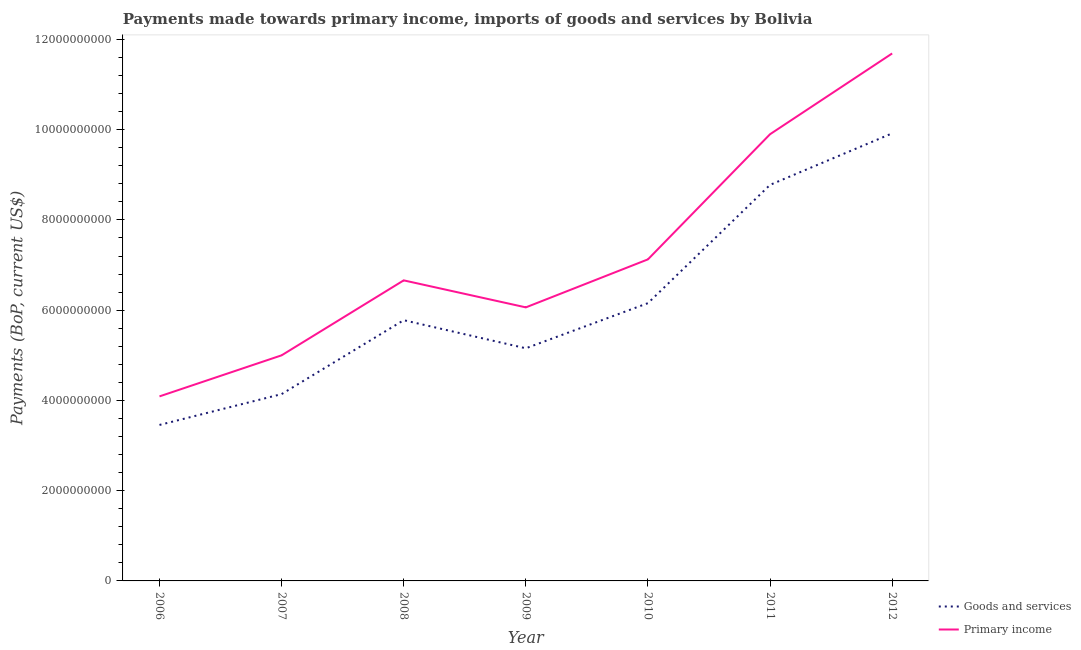How many different coloured lines are there?
Provide a succinct answer. 2. What is the payments made towards primary income in 2010?
Keep it short and to the point. 7.13e+09. Across all years, what is the maximum payments made towards goods and services?
Keep it short and to the point. 9.92e+09. Across all years, what is the minimum payments made towards primary income?
Ensure brevity in your answer.  4.09e+09. What is the total payments made towards goods and services in the graph?
Offer a terse response. 4.34e+1. What is the difference between the payments made towards goods and services in 2008 and that in 2012?
Make the answer very short. -4.14e+09. What is the difference between the payments made towards goods and services in 2011 and the payments made towards primary income in 2010?
Provide a succinct answer. 1.65e+09. What is the average payments made towards goods and services per year?
Provide a short and direct response. 6.20e+09. In the year 2010, what is the difference between the payments made towards goods and services and payments made towards primary income?
Your answer should be compact. -9.71e+08. In how many years, is the payments made towards goods and services greater than 10400000000 US$?
Ensure brevity in your answer.  0. What is the ratio of the payments made towards goods and services in 2006 to that in 2010?
Offer a terse response. 0.56. Is the payments made towards primary income in 2008 less than that in 2009?
Provide a short and direct response. No. What is the difference between the highest and the second highest payments made towards primary income?
Provide a short and direct response. 1.79e+09. What is the difference between the highest and the lowest payments made towards primary income?
Your answer should be compact. 7.60e+09. In how many years, is the payments made towards primary income greater than the average payments made towards primary income taken over all years?
Your answer should be compact. 2. Is the sum of the payments made towards goods and services in 2008 and 2010 greater than the maximum payments made towards primary income across all years?
Ensure brevity in your answer.  Yes. Does the payments made towards primary income monotonically increase over the years?
Your answer should be compact. No. Is the payments made towards primary income strictly greater than the payments made towards goods and services over the years?
Your answer should be compact. Yes. How many lines are there?
Your answer should be very brief. 2. Where does the legend appear in the graph?
Provide a short and direct response. Bottom right. How are the legend labels stacked?
Offer a terse response. Vertical. What is the title of the graph?
Your answer should be very brief. Payments made towards primary income, imports of goods and services by Bolivia. Does "Current US$" appear as one of the legend labels in the graph?
Provide a succinct answer. No. What is the label or title of the Y-axis?
Your answer should be very brief. Payments (BoP, current US$). What is the Payments (BoP, current US$) of Goods and services in 2006?
Ensure brevity in your answer.  3.46e+09. What is the Payments (BoP, current US$) in Primary income in 2006?
Make the answer very short. 4.09e+09. What is the Payments (BoP, current US$) of Goods and services in 2007?
Provide a succinct answer. 4.14e+09. What is the Payments (BoP, current US$) in Primary income in 2007?
Make the answer very short. 5.00e+09. What is the Payments (BoP, current US$) in Goods and services in 2008?
Ensure brevity in your answer.  5.78e+09. What is the Payments (BoP, current US$) in Primary income in 2008?
Ensure brevity in your answer.  6.66e+09. What is the Payments (BoP, current US$) of Goods and services in 2009?
Offer a terse response. 5.16e+09. What is the Payments (BoP, current US$) of Primary income in 2009?
Your response must be concise. 6.06e+09. What is the Payments (BoP, current US$) in Goods and services in 2010?
Give a very brief answer. 6.16e+09. What is the Payments (BoP, current US$) in Primary income in 2010?
Offer a terse response. 7.13e+09. What is the Payments (BoP, current US$) in Goods and services in 2011?
Your response must be concise. 8.78e+09. What is the Payments (BoP, current US$) in Primary income in 2011?
Provide a short and direct response. 9.90e+09. What is the Payments (BoP, current US$) in Goods and services in 2012?
Offer a terse response. 9.92e+09. What is the Payments (BoP, current US$) in Primary income in 2012?
Offer a terse response. 1.17e+1. Across all years, what is the maximum Payments (BoP, current US$) of Goods and services?
Provide a succinct answer. 9.92e+09. Across all years, what is the maximum Payments (BoP, current US$) in Primary income?
Provide a succinct answer. 1.17e+1. Across all years, what is the minimum Payments (BoP, current US$) of Goods and services?
Give a very brief answer. 3.46e+09. Across all years, what is the minimum Payments (BoP, current US$) in Primary income?
Your response must be concise. 4.09e+09. What is the total Payments (BoP, current US$) in Goods and services in the graph?
Provide a succinct answer. 4.34e+1. What is the total Payments (BoP, current US$) of Primary income in the graph?
Keep it short and to the point. 5.05e+1. What is the difference between the Payments (BoP, current US$) in Goods and services in 2006 and that in 2007?
Offer a terse response. -6.83e+08. What is the difference between the Payments (BoP, current US$) in Primary income in 2006 and that in 2007?
Provide a short and direct response. -9.10e+08. What is the difference between the Payments (BoP, current US$) in Goods and services in 2006 and that in 2008?
Offer a terse response. -2.32e+09. What is the difference between the Payments (BoP, current US$) of Primary income in 2006 and that in 2008?
Offer a terse response. -2.57e+09. What is the difference between the Payments (BoP, current US$) in Goods and services in 2006 and that in 2009?
Ensure brevity in your answer.  -1.70e+09. What is the difference between the Payments (BoP, current US$) in Primary income in 2006 and that in 2009?
Offer a terse response. -1.97e+09. What is the difference between the Payments (BoP, current US$) in Goods and services in 2006 and that in 2010?
Your response must be concise. -2.70e+09. What is the difference between the Payments (BoP, current US$) of Primary income in 2006 and that in 2010?
Your answer should be very brief. -3.04e+09. What is the difference between the Payments (BoP, current US$) of Goods and services in 2006 and that in 2011?
Keep it short and to the point. -5.32e+09. What is the difference between the Payments (BoP, current US$) of Primary income in 2006 and that in 2011?
Provide a succinct answer. -5.81e+09. What is the difference between the Payments (BoP, current US$) of Goods and services in 2006 and that in 2012?
Make the answer very short. -6.46e+09. What is the difference between the Payments (BoP, current US$) of Primary income in 2006 and that in 2012?
Your answer should be very brief. -7.60e+09. What is the difference between the Payments (BoP, current US$) of Goods and services in 2007 and that in 2008?
Offer a very short reply. -1.64e+09. What is the difference between the Payments (BoP, current US$) of Primary income in 2007 and that in 2008?
Your response must be concise. -1.66e+09. What is the difference between the Payments (BoP, current US$) of Goods and services in 2007 and that in 2009?
Give a very brief answer. -1.02e+09. What is the difference between the Payments (BoP, current US$) in Primary income in 2007 and that in 2009?
Your response must be concise. -1.06e+09. What is the difference between the Payments (BoP, current US$) in Goods and services in 2007 and that in 2010?
Make the answer very short. -2.02e+09. What is the difference between the Payments (BoP, current US$) of Primary income in 2007 and that in 2010?
Your response must be concise. -2.13e+09. What is the difference between the Payments (BoP, current US$) of Goods and services in 2007 and that in 2011?
Offer a very short reply. -4.64e+09. What is the difference between the Payments (BoP, current US$) of Primary income in 2007 and that in 2011?
Your response must be concise. -4.90e+09. What is the difference between the Payments (BoP, current US$) in Goods and services in 2007 and that in 2012?
Your response must be concise. -5.78e+09. What is the difference between the Payments (BoP, current US$) of Primary income in 2007 and that in 2012?
Your answer should be very brief. -6.69e+09. What is the difference between the Payments (BoP, current US$) of Goods and services in 2008 and that in 2009?
Provide a succinct answer. 6.22e+08. What is the difference between the Payments (BoP, current US$) in Primary income in 2008 and that in 2009?
Offer a terse response. 5.99e+08. What is the difference between the Payments (BoP, current US$) of Goods and services in 2008 and that in 2010?
Make the answer very short. -3.77e+08. What is the difference between the Payments (BoP, current US$) in Primary income in 2008 and that in 2010?
Ensure brevity in your answer.  -4.65e+08. What is the difference between the Payments (BoP, current US$) of Goods and services in 2008 and that in 2011?
Provide a succinct answer. -3.00e+09. What is the difference between the Payments (BoP, current US$) in Primary income in 2008 and that in 2011?
Make the answer very short. -3.24e+09. What is the difference between the Payments (BoP, current US$) of Goods and services in 2008 and that in 2012?
Offer a very short reply. -4.14e+09. What is the difference between the Payments (BoP, current US$) in Primary income in 2008 and that in 2012?
Offer a very short reply. -5.03e+09. What is the difference between the Payments (BoP, current US$) of Goods and services in 2009 and that in 2010?
Provide a succinct answer. -1.00e+09. What is the difference between the Payments (BoP, current US$) in Primary income in 2009 and that in 2010?
Offer a terse response. -1.06e+09. What is the difference between the Payments (BoP, current US$) in Goods and services in 2009 and that in 2011?
Keep it short and to the point. -3.62e+09. What is the difference between the Payments (BoP, current US$) in Primary income in 2009 and that in 2011?
Keep it short and to the point. -3.84e+09. What is the difference between the Payments (BoP, current US$) of Goods and services in 2009 and that in 2012?
Offer a terse response. -4.76e+09. What is the difference between the Payments (BoP, current US$) in Primary income in 2009 and that in 2012?
Give a very brief answer. -5.63e+09. What is the difference between the Payments (BoP, current US$) in Goods and services in 2010 and that in 2011?
Provide a short and direct response. -2.62e+09. What is the difference between the Payments (BoP, current US$) in Primary income in 2010 and that in 2011?
Make the answer very short. -2.77e+09. What is the difference between the Payments (BoP, current US$) of Goods and services in 2010 and that in 2012?
Your response must be concise. -3.76e+09. What is the difference between the Payments (BoP, current US$) of Primary income in 2010 and that in 2012?
Offer a very short reply. -4.56e+09. What is the difference between the Payments (BoP, current US$) in Goods and services in 2011 and that in 2012?
Offer a very short reply. -1.14e+09. What is the difference between the Payments (BoP, current US$) of Primary income in 2011 and that in 2012?
Ensure brevity in your answer.  -1.79e+09. What is the difference between the Payments (BoP, current US$) of Goods and services in 2006 and the Payments (BoP, current US$) of Primary income in 2007?
Offer a terse response. -1.54e+09. What is the difference between the Payments (BoP, current US$) of Goods and services in 2006 and the Payments (BoP, current US$) of Primary income in 2008?
Give a very brief answer. -3.20e+09. What is the difference between the Payments (BoP, current US$) in Goods and services in 2006 and the Payments (BoP, current US$) in Primary income in 2009?
Give a very brief answer. -2.61e+09. What is the difference between the Payments (BoP, current US$) in Goods and services in 2006 and the Payments (BoP, current US$) in Primary income in 2010?
Offer a terse response. -3.67e+09. What is the difference between the Payments (BoP, current US$) of Goods and services in 2006 and the Payments (BoP, current US$) of Primary income in 2011?
Your response must be concise. -6.44e+09. What is the difference between the Payments (BoP, current US$) in Goods and services in 2006 and the Payments (BoP, current US$) in Primary income in 2012?
Your answer should be compact. -8.23e+09. What is the difference between the Payments (BoP, current US$) of Goods and services in 2007 and the Payments (BoP, current US$) of Primary income in 2008?
Your answer should be compact. -2.52e+09. What is the difference between the Payments (BoP, current US$) in Goods and services in 2007 and the Payments (BoP, current US$) in Primary income in 2009?
Your response must be concise. -1.92e+09. What is the difference between the Payments (BoP, current US$) of Goods and services in 2007 and the Payments (BoP, current US$) of Primary income in 2010?
Keep it short and to the point. -2.99e+09. What is the difference between the Payments (BoP, current US$) in Goods and services in 2007 and the Payments (BoP, current US$) in Primary income in 2011?
Ensure brevity in your answer.  -5.76e+09. What is the difference between the Payments (BoP, current US$) of Goods and services in 2007 and the Payments (BoP, current US$) of Primary income in 2012?
Your answer should be very brief. -7.55e+09. What is the difference between the Payments (BoP, current US$) in Goods and services in 2008 and the Payments (BoP, current US$) in Primary income in 2009?
Give a very brief answer. -2.84e+08. What is the difference between the Payments (BoP, current US$) of Goods and services in 2008 and the Payments (BoP, current US$) of Primary income in 2010?
Provide a succinct answer. -1.35e+09. What is the difference between the Payments (BoP, current US$) of Goods and services in 2008 and the Payments (BoP, current US$) of Primary income in 2011?
Your answer should be very brief. -4.12e+09. What is the difference between the Payments (BoP, current US$) of Goods and services in 2008 and the Payments (BoP, current US$) of Primary income in 2012?
Keep it short and to the point. -5.91e+09. What is the difference between the Payments (BoP, current US$) of Goods and services in 2009 and the Payments (BoP, current US$) of Primary income in 2010?
Make the answer very short. -1.97e+09. What is the difference between the Payments (BoP, current US$) in Goods and services in 2009 and the Payments (BoP, current US$) in Primary income in 2011?
Offer a very short reply. -4.74e+09. What is the difference between the Payments (BoP, current US$) of Goods and services in 2009 and the Payments (BoP, current US$) of Primary income in 2012?
Your answer should be very brief. -6.53e+09. What is the difference between the Payments (BoP, current US$) in Goods and services in 2010 and the Payments (BoP, current US$) in Primary income in 2011?
Your response must be concise. -3.74e+09. What is the difference between the Payments (BoP, current US$) of Goods and services in 2010 and the Payments (BoP, current US$) of Primary income in 2012?
Provide a short and direct response. -5.53e+09. What is the difference between the Payments (BoP, current US$) of Goods and services in 2011 and the Payments (BoP, current US$) of Primary income in 2012?
Ensure brevity in your answer.  -2.91e+09. What is the average Payments (BoP, current US$) of Goods and services per year?
Offer a very short reply. 6.20e+09. What is the average Payments (BoP, current US$) in Primary income per year?
Your answer should be very brief. 7.22e+09. In the year 2006, what is the difference between the Payments (BoP, current US$) in Goods and services and Payments (BoP, current US$) in Primary income?
Ensure brevity in your answer.  -6.33e+08. In the year 2007, what is the difference between the Payments (BoP, current US$) in Goods and services and Payments (BoP, current US$) in Primary income?
Your answer should be compact. -8.59e+08. In the year 2008, what is the difference between the Payments (BoP, current US$) in Goods and services and Payments (BoP, current US$) in Primary income?
Ensure brevity in your answer.  -8.83e+08. In the year 2009, what is the difference between the Payments (BoP, current US$) in Goods and services and Payments (BoP, current US$) in Primary income?
Give a very brief answer. -9.06e+08. In the year 2010, what is the difference between the Payments (BoP, current US$) of Goods and services and Payments (BoP, current US$) of Primary income?
Your response must be concise. -9.71e+08. In the year 2011, what is the difference between the Payments (BoP, current US$) of Goods and services and Payments (BoP, current US$) of Primary income?
Give a very brief answer. -1.12e+09. In the year 2012, what is the difference between the Payments (BoP, current US$) in Goods and services and Payments (BoP, current US$) in Primary income?
Give a very brief answer. -1.77e+09. What is the ratio of the Payments (BoP, current US$) of Goods and services in 2006 to that in 2007?
Offer a very short reply. 0.83. What is the ratio of the Payments (BoP, current US$) of Primary income in 2006 to that in 2007?
Offer a very short reply. 0.82. What is the ratio of the Payments (BoP, current US$) of Goods and services in 2006 to that in 2008?
Provide a succinct answer. 0.6. What is the ratio of the Payments (BoP, current US$) of Primary income in 2006 to that in 2008?
Make the answer very short. 0.61. What is the ratio of the Payments (BoP, current US$) of Goods and services in 2006 to that in 2009?
Make the answer very short. 0.67. What is the ratio of the Payments (BoP, current US$) in Primary income in 2006 to that in 2009?
Give a very brief answer. 0.67. What is the ratio of the Payments (BoP, current US$) in Goods and services in 2006 to that in 2010?
Offer a very short reply. 0.56. What is the ratio of the Payments (BoP, current US$) of Primary income in 2006 to that in 2010?
Provide a short and direct response. 0.57. What is the ratio of the Payments (BoP, current US$) in Goods and services in 2006 to that in 2011?
Provide a succinct answer. 0.39. What is the ratio of the Payments (BoP, current US$) in Primary income in 2006 to that in 2011?
Ensure brevity in your answer.  0.41. What is the ratio of the Payments (BoP, current US$) in Goods and services in 2006 to that in 2012?
Offer a very short reply. 0.35. What is the ratio of the Payments (BoP, current US$) of Primary income in 2006 to that in 2012?
Give a very brief answer. 0.35. What is the ratio of the Payments (BoP, current US$) in Goods and services in 2007 to that in 2008?
Your answer should be compact. 0.72. What is the ratio of the Payments (BoP, current US$) in Primary income in 2007 to that in 2008?
Make the answer very short. 0.75. What is the ratio of the Payments (BoP, current US$) in Goods and services in 2007 to that in 2009?
Offer a very short reply. 0.8. What is the ratio of the Payments (BoP, current US$) in Primary income in 2007 to that in 2009?
Provide a short and direct response. 0.82. What is the ratio of the Payments (BoP, current US$) of Goods and services in 2007 to that in 2010?
Your answer should be very brief. 0.67. What is the ratio of the Payments (BoP, current US$) in Primary income in 2007 to that in 2010?
Make the answer very short. 0.7. What is the ratio of the Payments (BoP, current US$) in Goods and services in 2007 to that in 2011?
Your answer should be very brief. 0.47. What is the ratio of the Payments (BoP, current US$) in Primary income in 2007 to that in 2011?
Provide a short and direct response. 0.51. What is the ratio of the Payments (BoP, current US$) in Goods and services in 2007 to that in 2012?
Give a very brief answer. 0.42. What is the ratio of the Payments (BoP, current US$) in Primary income in 2007 to that in 2012?
Provide a succinct answer. 0.43. What is the ratio of the Payments (BoP, current US$) of Goods and services in 2008 to that in 2009?
Your response must be concise. 1.12. What is the ratio of the Payments (BoP, current US$) in Primary income in 2008 to that in 2009?
Offer a very short reply. 1.1. What is the ratio of the Payments (BoP, current US$) in Goods and services in 2008 to that in 2010?
Provide a succinct answer. 0.94. What is the ratio of the Payments (BoP, current US$) of Primary income in 2008 to that in 2010?
Offer a terse response. 0.93. What is the ratio of the Payments (BoP, current US$) of Goods and services in 2008 to that in 2011?
Your response must be concise. 0.66. What is the ratio of the Payments (BoP, current US$) of Primary income in 2008 to that in 2011?
Ensure brevity in your answer.  0.67. What is the ratio of the Payments (BoP, current US$) in Goods and services in 2008 to that in 2012?
Your answer should be compact. 0.58. What is the ratio of the Payments (BoP, current US$) in Primary income in 2008 to that in 2012?
Your answer should be very brief. 0.57. What is the ratio of the Payments (BoP, current US$) of Goods and services in 2009 to that in 2010?
Your answer should be very brief. 0.84. What is the ratio of the Payments (BoP, current US$) of Primary income in 2009 to that in 2010?
Make the answer very short. 0.85. What is the ratio of the Payments (BoP, current US$) of Goods and services in 2009 to that in 2011?
Make the answer very short. 0.59. What is the ratio of the Payments (BoP, current US$) of Primary income in 2009 to that in 2011?
Offer a very short reply. 0.61. What is the ratio of the Payments (BoP, current US$) in Goods and services in 2009 to that in 2012?
Make the answer very short. 0.52. What is the ratio of the Payments (BoP, current US$) in Primary income in 2009 to that in 2012?
Give a very brief answer. 0.52. What is the ratio of the Payments (BoP, current US$) of Goods and services in 2010 to that in 2011?
Give a very brief answer. 0.7. What is the ratio of the Payments (BoP, current US$) in Primary income in 2010 to that in 2011?
Ensure brevity in your answer.  0.72. What is the ratio of the Payments (BoP, current US$) in Goods and services in 2010 to that in 2012?
Provide a succinct answer. 0.62. What is the ratio of the Payments (BoP, current US$) in Primary income in 2010 to that in 2012?
Give a very brief answer. 0.61. What is the ratio of the Payments (BoP, current US$) of Goods and services in 2011 to that in 2012?
Make the answer very short. 0.88. What is the ratio of the Payments (BoP, current US$) of Primary income in 2011 to that in 2012?
Keep it short and to the point. 0.85. What is the difference between the highest and the second highest Payments (BoP, current US$) in Goods and services?
Your response must be concise. 1.14e+09. What is the difference between the highest and the second highest Payments (BoP, current US$) of Primary income?
Your response must be concise. 1.79e+09. What is the difference between the highest and the lowest Payments (BoP, current US$) of Goods and services?
Your response must be concise. 6.46e+09. What is the difference between the highest and the lowest Payments (BoP, current US$) of Primary income?
Your answer should be very brief. 7.60e+09. 